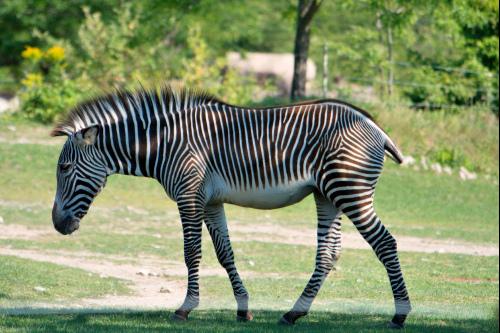Is the zebra eating?
Write a very short answer. No. Is the zebra walking?
Keep it brief. Yes. What is the zebra doing?
Quick response, please. Walking. Is the zebra in a zoo?
Short answer required. Yes. 